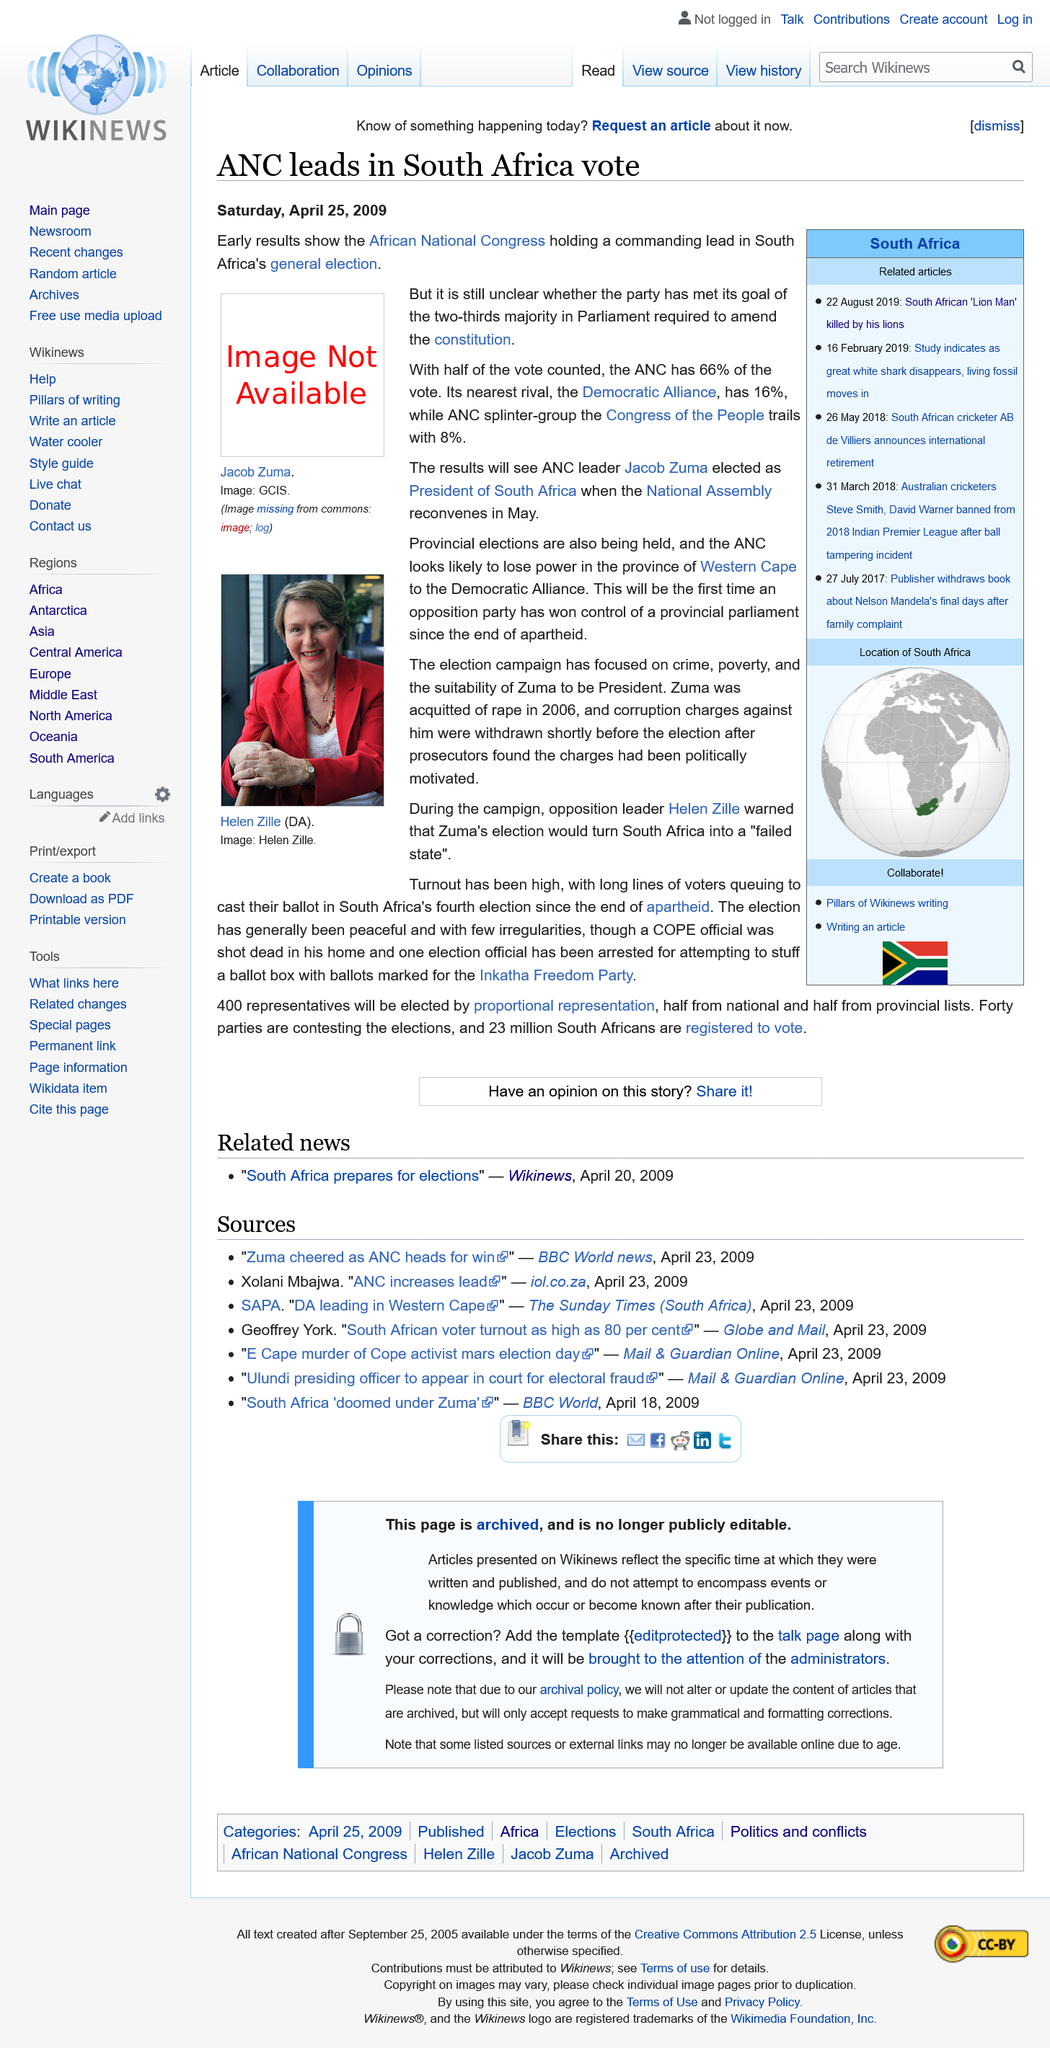Highlight a few significant elements in this photo. The National Assembly reconvenes in May. The provincial elections are taking place in the Western Cape province. With half the vote counted, the ANC has received 66% of the vote. The photograph features a woman named Helen Zille. The African National Congress, commonly known as ANC, is a political organization that represents the people of Africa and is dedicated to promoting the interests of the African community. ANC is a symbol of the struggle for freedom and democracy in Africa and has been at the forefront of the fight against apartheid and oppression. The ANC is committed to building a better future for all the people of Africa and strives to create a society that is just, equal, and free. 